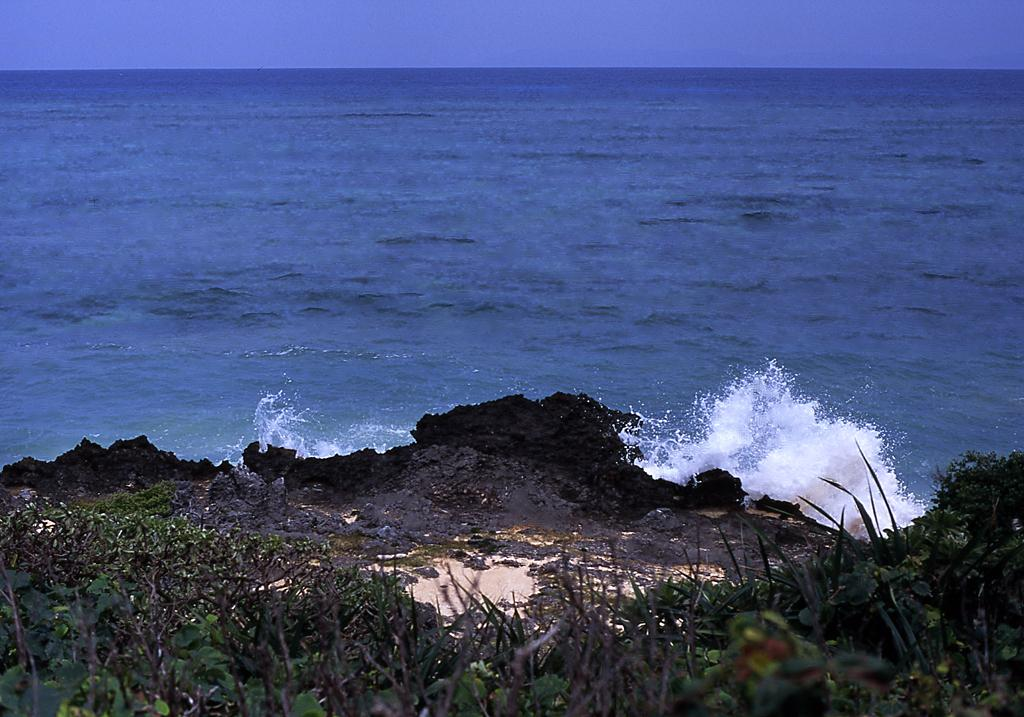What type of natural environment can be seen in the background of the image? There is an ocean in the background of the image. What else is visible in the image besides the ocean? The sky is visible above the ocean. What type of vegetation is present in the image? There are plants on the land in the front of the image. What type of comb is used to manage the ocean waves in the image? There is no comb present in the image, and the ocean waves are not managed by any comb. 